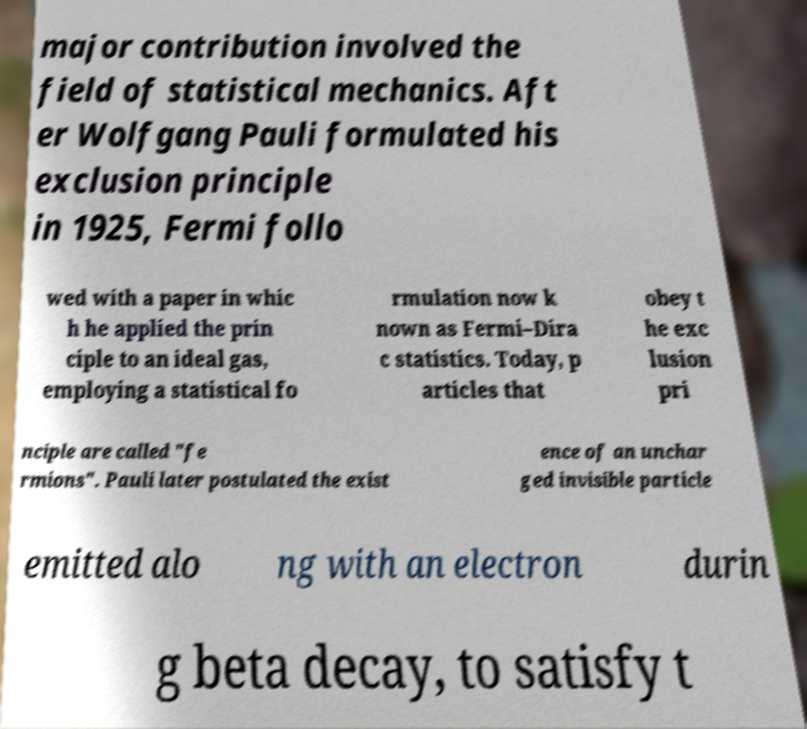Can you accurately transcribe the text from the provided image for me? major contribution involved the field of statistical mechanics. Aft er Wolfgang Pauli formulated his exclusion principle in 1925, Fermi follo wed with a paper in whic h he applied the prin ciple to an ideal gas, employing a statistical fo rmulation now k nown as Fermi–Dira c statistics. Today, p articles that obey t he exc lusion pri nciple are called "fe rmions". Pauli later postulated the exist ence of an unchar ged invisible particle emitted alo ng with an electron durin g beta decay, to satisfy t 